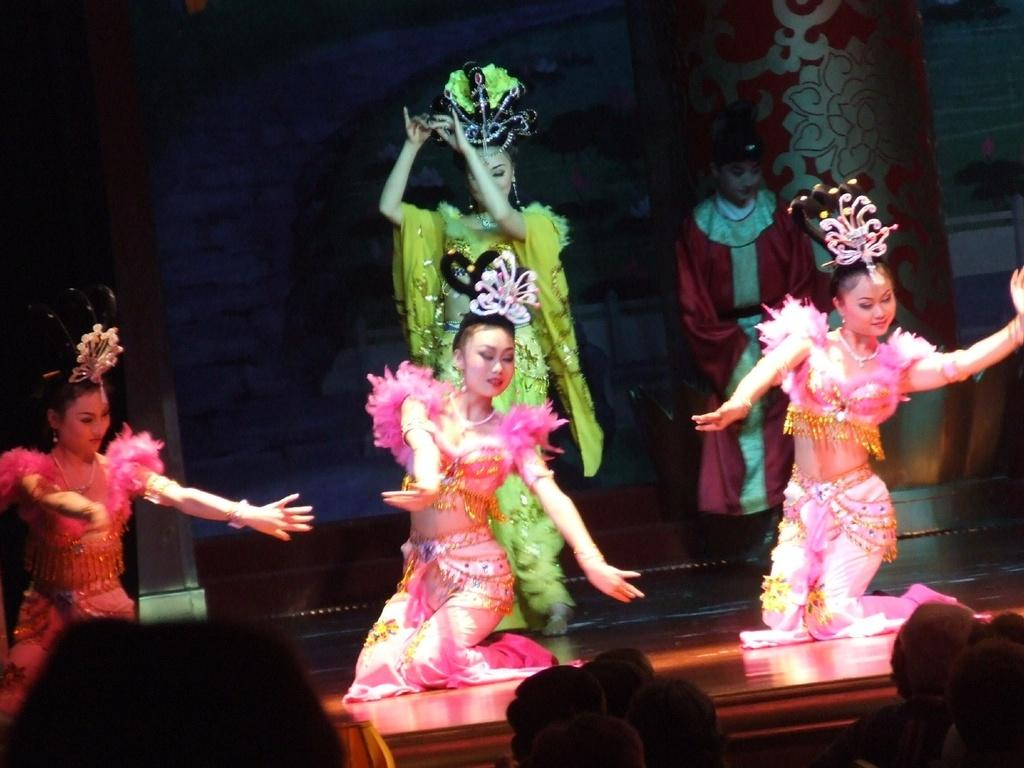What are the girls in the image doing? The girls in the image are dancing on the floor. How many girls are dancing? There are two girls standing, but the facts do not specify how many are dancing. What are the people in the image doing? The people in the image are sitting and watching the dance. What type of waste can be seen on the floor during the dance? There is no mention of waste in the image, so it cannot be determined if any waste is present. 